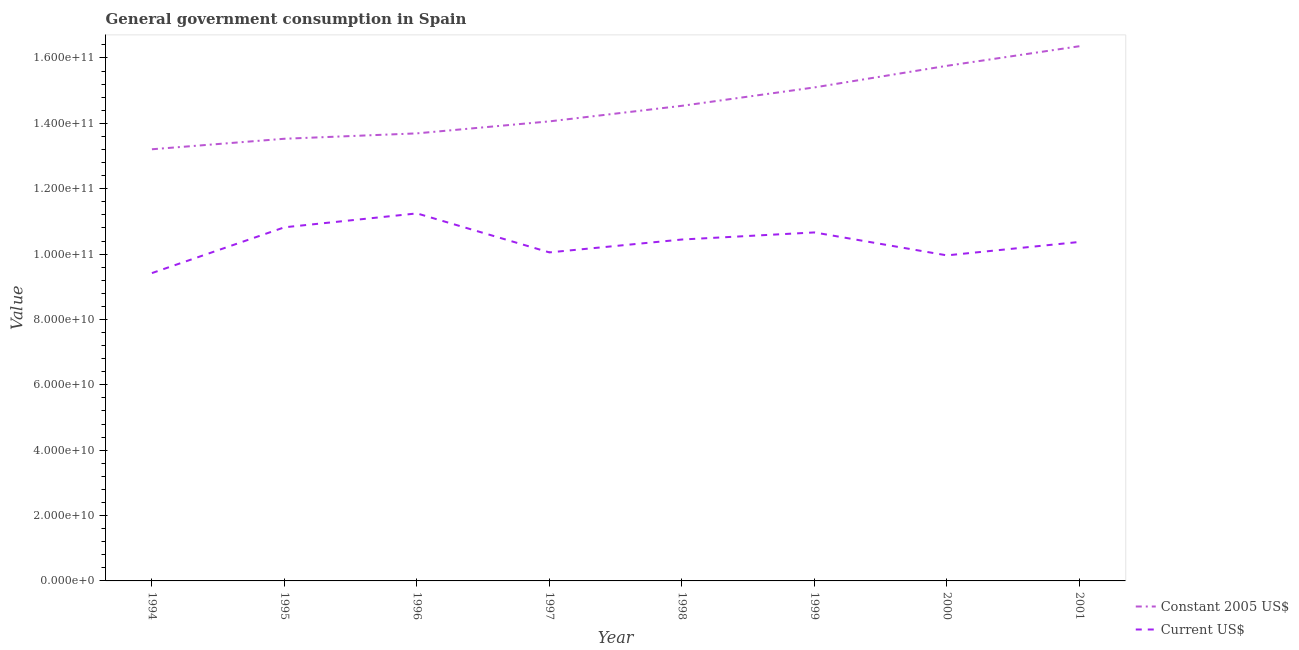How many different coloured lines are there?
Your response must be concise. 2. Does the line corresponding to value consumed in current us$ intersect with the line corresponding to value consumed in constant 2005 us$?
Your response must be concise. No. What is the value consumed in current us$ in 1996?
Provide a short and direct response. 1.12e+11. Across all years, what is the maximum value consumed in constant 2005 us$?
Offer a terse response. 1.64e+11. Across all years, what is the minimum value consumed in constant 2005 us$?
Make the answer very short. 1.32e+11. What is the total value consumed in constant 2005 us$ in the graph?
Provide a succinct answer. 1.16e+12. What is the difference between the value consumed in constant 2005 us$ in 1994 and that in 1998?
Your answer should be very brief. -1.33e+1. What is the difference between the value consumed in constant 2005 us$ in 1994 and the value consumed in current us$ in 1995?
Ensure brevity in your answer.  2.39e+1. What is the average value consumed in current us$ per year?
Make the answer very short. 1.04e+11. In the year 1998, what is the difference between the value consumed in constant 2005 us$ and value consumed in current us$?
Your answer should be very brief. 4.09e+1. In how many years, is the value consumed in constant 2005 us$ greater than 60000000000?
Provide a short and direct response. 8. What is the ratio of the value consumed in constant 2005 us$ in 1996 to that in 1999?
Your answer should be compact. 0.91. Is the value consumed in constant 2005 us$ in 1997 less than that in 1998?
Ensure brevity in your answer.  Yes. What is the difference between the highest and the second highest value consumed in current us$?
Provide a short and direct response. 4.25e+09. What is the difference between the highest and the lowest value consumed in current us$?
Keep it short and to the point. 1.83e+1. Is the sum of the value consumed in current us$ in 1997 and 1999 greater than the maximum value consumed in constant 2005 us$ across all years?
Offer a very short reply. Yes. Is the value consumed in current us$ strictly greater than the value consumed in constant 2005 us$ over the years?
Keep it short and to the point. No. How many lines are there?
Give a very brief answer. 2. What is the difference between two consecutive major ticks on the Y-axis?
Ensure brevity in your answer.  2.00e+1. Are the values on the major ticks of Y-axis written in scientific E-notation?
Provide a short and direct response. Yes. Does the graph contain any zero values?
Give a very brief answer. No. Does the graph contain grids?
Your answer should be very brief. No. How many legend labels are there?
Offer a very short reply. 2. How are the legend labels stacked?
Offer a very short reply. Vertical. What is the title of the graph?
Your response must be concise. General government consumption in Spain. Does "Non-resident workers" appear as one of the legend labels in the graph?
Ensure brevity in your answer.  No. What is the label or title of the X-axis?
Keep it short and to the point. Year. What is the label or title of the Y-axis?
Make the answer very short. Value. What is the Value in Constant 2005 US$ in 1994?
Keep it short and to the point. 1.32e+11. What is the Value in Current US$ in 1994?
Your answer should be compact. 9.42e+1. What is the Value of Constant 2005 US$ in 1995?
Keep it short and to the point. 1.35e+11. What is the Value of Current US$ in 1995?
Provide a succinct answer. 1.08e+11. What is the Value in Constant 2005 US$ in 1996?
Offer a terse response. 1.37e+11. What is the Value of Current US$ in 1996?
Provide a short and direct response. 1.12e+11. What is the Value in Constant 2005 US$ in 1997?
Your answer should be compact. 1.41e+11. What is the Value in Current US$ in 1997?
Your answer should be very brief. 1.01e+11. What is the Value in Constant 2005 US$ in 1998?
Offer a terse response. 1.45e+11. What is the Value in Current US$ in 1998?
Give a very brief answer. 1.04e+11. What is the Value of Constant 2005 US$ in 1999?
Offer a terse response. 1.51e+11. What is the Value in Current US$ in 1999?
Ensure brevity in your answer.  1.07e+11. What is the Value in Constant 2005 US$ in 2000?
Your answer should be very brief. 1.58e+11. What is the Value in Current US$ in 2000?
Provide a short and direct response. 9.96e+1. What is the Value of Constant 2005 US$ in 2001?
Ensure brevity in your answer.  1.64e+11. What is the Value in Current US$ in 2001?
Keep it short and to the point. 1.04e+11. Across all years, what is the maximum Value of Constant 2005 US$?
Your answer should be very brief. 1.64e+11. Across all years, what is the maximum Value in Current US$?
Offer a terse response. 1.12e+11. Across all years, what is the minimum Value in Constant 2005 US$?
Offer a very short reply. 1.32e+11. Across all years, what is the minimum Value of Current US$?
Offer a very short reply. 9.42e+1. What is the total Value of Constant 2005 US$ in the graph?
Offer a terse response. 1.16e+12. What is the total Value of Current US$ in the graph?
Give a very brief answer. 8.30e+11. What is the difference between the Value in Constant 2005 US$ in 1994 and that in 1995?
Provide a succinct answer. -3.22e+09. What is the difference between the Value of Current US$ in 1994 and that in 1995?
Provide a succinct answer. -1.40e+1. What is the difference between the Value of Constant 2005 US$ in 1994 and that in 1996?
Offer a terse response. -4.86e+09. What is the difference between the Value in Current US$ in 1994 and that in 1996?
Give a very brief answer. -1.83e+1. What is the difference between the Value of Constant 2005 US$ in 1994 and that in 1997?
Keep it short and to the point. -8.53e+09. What is the difference between the Value of Current US$ in 1994 and that in 1997?
Make the answer very short. -6.33e+09. What is the difference between the Value in Constant 2005 US$ in 1994 and that in 1998?
Make the answer very short. -1.33e+1. What is the difference between the Value in Current US$ in 1994 and that in 1998?
Offer a very short reply. -1.03e+1. What is the difference between the Value in Constant 2005 US$ in 1994 and that in 1999?
Your answer should be very brief. -1.89e+1. What is the difference between the Value in Current US$ in 1994 and that in 1999?
Offer a very short reply. -1.24e+1. What is the difference between the Value of Constant 2005 US$ in 1994 and that in 2000?
Provide a succinct answer. -2.55e+1. What is the difference between the Value in Current US$ in 1994 and that in 2000?
Ensure brevity in your answer.  -5.42e+09. What is the difference between the Value in Constant 2005 US$ in 1994 and that in 2001?
Give a very brief answer. -3.15e+1. What is the difference between the Value in Current US$ in 1994 and that in 2001?
Offer a terse response. -9.53e+09. What is the difference between the Value in Constant 2005 US$ in 1995 and that in 1996?
Provide a short and direct response. -1.65e+09. What is the difference between the Value of Current US$ in 1995 and that in 1996?
Your response must be concise. -4.25e+09. What is the difference between the Value in Constant 2005 US$ in 1995 and that in 1997?
Keep it short and to the point. -5.32e+09. What is the difference between the Value in Current US$ in 1995 and that in 1997?
Ensure brevity in your answer.  7.68e+09. What is the difference between the Value in Constant 2005 US$ in 1995 and that in 1998?
Your answer should be compact. -1.01e+1. What is the difference between the Value of Current US$ in 1995 and that in 1998?
Keep it short and to the point. 3.74e+09. What is the difference between the Value in Constant 2005 US$ in 1995 and that in 1999?
Your answer should be very brief. -1.57e+1. What is the difference between the Value in Current US$ in 1995 and that in 1999?
Provide a succinct answer. 1.57e+09. What is the difference between the Value of Constant 2005 US$ in 1995 and that in 2000?
Keep it short and to the point. -2.23e+1. What is the difference between the Value in Current US$ in 1995 and that in 2000?
Offer a very short reply. 8.59e+09. What is the difference between the Value of Constant 2005 US$ in 1995 and that in 2001?
Ensure brevity in your answer.  -2.83e+1. What is the difference between the Value in Current US$ in 1995 and that in 2001?
Your answer should be very brief. 4.48e+09. What is the difference between the Value in Constant 2005 US$ in 1996 and that in 1997?
Your answer should be very brief. -3.67e+09. What is the difference between the Value in Current US$ in 1996 and that in 1997?
Make the answer very short. 1.19e+1. What is the difference between the Value in Constant 2005 US$ in 1996 and that in 1998?
Make the answer very short. -8.43e+09. What is the difference between the Value of Current US$ in 1996 and that in 1998?
Make the answer very short. 7.99e+09. What is the difference between the Value in Constant 2005 US$ in 1996 and that in 1999?
Your answer should be compact. -1.41e+1. What is the difference between the Value in Current US$ in 1996 and that in 1999?
Offer a terse response. 5.82e+09. What is the difference between the Value in Constant 2005 US$ in 1996 and that in 2000?
Offer a terse response. -2.07e+1. What is the difference between the Value of Current US$ in 1996 and that in 2000?
Make the answer very short. 1.28e+1. What is the difference between the Value in Constant 2005 US$ in 1996 and that in 2001?
Make the answer very short. -2.67e+1. What is the difference between the Value in Current US$ in 1996 and that in 2001?
Ensure brevity in your answer.  8.74e+09. What is the difference between the Value in Constant 2005 US$ in 1997 and that in 1998?
Make the answer very short. -4.76e+09. What is the difference between the Value in Current US$ in 1997 and that in 1998?
Offer a very short reply. -3.94e+09. What is the difference between the Value of Constant 2005 US$ in 1997 and that in 1999?
Provide a short and direct response. -1.04e+1. What is the difference between the Value of Current US$ in 1997 and that in 1999?
Your answer should be compact. -6.11e+09. What is the difference between the Value in Constant 2005 US$ in 1997 and that in 2000?
Your response must be concise. -1.70e+1. What is the difference between the Value of Current US$ in 1997 and that in 2000?
Give a very brief answer. 9.12e+08. What is the difference between the Value in Constant 2005 US$ in 1997 and that in 2001?
Give a very brief answer. -2.30e+1. What is the difference between the Value of Current US$ in 1997 and that in 2001?
Make the answer very short. -3.20e+09. What is the difference between the Value of Constant 2005 US$ in 1998 and that in 1999?
Your response must be concise. -5.63e+09. What is the difference between the Value of Current US$ in 1998 and that in 1999?
Your response must be concise. -2.17e+09. What is the difference between the Value in Constant 2005 US$ in 1998 and that in 2000?
Ensure brevity in your answer.  -1.22e+1. What is the difference between the Value of Current US$ in 1998 and that in 2000?
Your answer should be very brief. 4.85e+09. What is the difference between the Value of Constant 2005 US$ in 1998 and that in 2001?
Give a very brief answer. -1.82e+1. What is the difference between the Value of Current US$ in 1998 and that in 2001?
Give a very brief answer. 7.44e+08. What is the difference between the Value in Constant 2005 US$ in 1999 and that in 2000?
Keep it short and to the point. -6.61e+09. What is the difference between the Value in Current US$ in 1999 and that in 2000?
Your answer should be very brief. 7.02e+09. What is the difference between the Value in Constant 2005 US$ in 1999 and that in 2001?
Make the answer very short. -1.26e+1. What is the difference between the Value of Current US$ in 1999 and that in 2001?
Provide a succinct answer. 2.91e+09. What is the difference between the Value of Constant 2005 US$ in 2000 and that in 2001?
Your answer should be compact. -6.00e+09. What is the difference between the Value in Current US$ in 2000 and that in 2001?
Your response must be concise. -4.11e+09. What is the difference between the Value of Constant 2005 US$ in 1994 and the Value of Current US$ in 1995?
Offer a very short reply. 2.39e+1. What is the difference between the Value of Constant 2005 US$ in 1994 and the Value of Current US$ in 1996?
Provide a succinct answer. 1.96e+1. What is the difference between the Value in Constant 2005 US$ in 1994 and the Value in Current US$ in 1997?
Provide a short and direct response. 3.16e+1. What is the difference between the Value of Constant 2005 US$ in 1994 and the Value of Current US$ in 1998?
Offer a very short reply. 2.76e+1. What is the difference between the Value of Constant 2005 US$ in 1994 and the Value of Current US$ in 1999?
Offer a terse response. 2.54e+1. What is the difference between the Value in Constant 2005 US$ in 1994 and the Value in Current US$ in 2000?
Offer a very short reply. 3.25e+1. What is the difference between the Value of Constant 2005 US$ in 1994 and the Value of Current US$ in 2001?
Your answer should be compact. 2.84e+1. What is the difference between the Value in Constant 2005 US$ in 1995 and the Value in Current US$ in 1996?
Your response must be concise. 2.28e+1. What is the difference between the Value in Constant 2005 US$ in 1995 and the Value in Current US$ in 1997?
Ensure brevity in your answer.  3.48e+1. What is the difference between the Value in Constant 2005 US$ in 1995 and the Value in Current US$ in 1998?
Your answer should be compact. 3.08e+1. What is the difference between the Value in Constant 2005 US$ in 1995 and the Value in Current US$ in 1999?
Provide a succinct answer. 2.87e+1. What is the difference between the Value in Constant 2005 US$ in 1995 and the Value in Current US$ in 2000?
Your answer should be very brief. 3.57e+1. What is the difference between the Value of Constant 2005 US$ in 1995 and the Value of Current US$ in 2001?
Keep it short and to the point. 3.16e+1. What is the difference between the Value in Constant 2005 US$ in 1996 and the Value in Current US$ in 1997?
Keep it short and to the point. 3.64e+1. What is the difference between the Value of Constant 2005 US$ in 1996 and the Value of Current US$ in 1998?
Provide a succinct answer. 3.25e+1. What is the difference between the Value in Constant 2005 US$ in 1996 and the Value in Current US$ in 1999?
Keep it short and to the point. 3.03e+1. What is the difference between the Value in Constant 2005 US$ in 1996 and the Value in Current US$ in 2000?
Your answer should be compact. 3.73e+1. What is the difference between the Value of Constant 2005 US$ in 1996 and the Value of Current US$ in 2001?
Your answer should be compact. 3.32e+1. What is the difference between the Value of Constant 2005 US$ in 1997 and the Value of Current US$ in 1998?
Your response must be concise. 3.61e+1. What is the difference between the Value in Constant 2005 US$ in 1997 and the Value in Current US$ in 1999?
Give a very brief answer. 3.40e+1. What is the difference between the Value in Constant 2005 US$ in 1997 and the Value in Current US$ in 2000?
Offer a very short reply. 4.10e+1. What is the difference between the Value in Constant 2005 US$ in 1997 and the Value in Current US$ in 2001?
Ensure brevity in your answer.  3.69e+1. What is the difference between the Value of Constant 2005 US$ in 1998 and the Value of Current US$ in 1999?
Your response must be concise. 3.87e+1. What is the difference between the Value in Constant 2005 US$ in 1998 and the Value in Current US$ in 2000?
Provide a succinct answer. 4.58e+1. What is the difference between the Value of Constant 2005 US$ in 1998 and the Value of Current US$ in 2001?
Your answer should be very brief. 4.17e+1. What is the difference between the Value of Constant 2005 US$ in 1999 and the Value of Current US$ in 2000?
Provide a short and direct response. 5.14e+1. What is the difference between the Value in Constant 2005 US$ in 1999 and the Value in Current US$ in 2001?
Provide a short and direct response. 4.73e+1. What is the difference between the Value in Constant 2005 US$ in 2000 and the Value in Current US$ in 2001?
Keep it short and to the point. 5.39e+1. What is the average Value in Constant 2005 US$ per year?
Offer a very short reply. 1.45e+11. What is the average Value in Current US$ per year?
Your answer should be very brief. 1.04e+11. In the year 1994, what is the difference between the Value of Constant 2005 US$ and Value of Current US$?
Your answer should be very brief. 3.79e+1. In the year 1995, what is the difference between the Value in Constant 2005 US$ and Value in Current US$?
Give a very brief answer. 2.71e+1. In the year 1996, what is the difference between the Value of Constant 2005 US$ and Value of Current US$?
Your response must be concise. 2.45e+1. In the year 1997, what is the difference between the Value in Constant 2005 US$ and Value in Current US$?
Offer a terse response. 4.01e+1. In the year 1998, what is the difference between the Value in Constant 2005 US$ and Value in Current US$?
Ensure brevity in your answer.  4.09e+1. In the year 1999, what is the difference between the Value of Constant 2005 US$ and Value of Current US$?
Your answer should be compact. 4.44e+1. In the year 2000, what is the difference between the Value in Constant 2005 US$ and Value in Current US$?
Your answer should be very brief. 5.80e+1. In the year 2001, what is the difference between the Value of Constant 2005 US$ and Value of Current US$?
Provide a succinct answer. 5.99e+1. What is the ratio of the Value of Constant 2005 US$ in 1994 to that in 1995?
Make the answer very short. 0.98. What is the ratio of the Value of Current US$ in 1994 to that in 1995?
Provide a succinct answer. 0.87. What is the ratio of the Value in Constant 2005 US$ in 1994 to that in 1996?
Your answer should be compact. 0.96. What is the ratio of the Value of Current US$ in 1994 to that in 1996?
Your answer should be very brief. 0.84. What is the ratio of the Value in Constant 2005 US$ in 1994 to that in 1997?
Your answer should be very brief. 0.94. What is the ratio of the Value in Current US$ in 1994 to that in 1997?
Ensure brevity in your answer.  0.94. What is the ratio of the Value in Constant 2005 US$ in 1994 to that in 1998?
Your response must be concise. 0.91. What is the ratio of the Value in Current US$ in 1994 to that in 1998?
Your response must be concise. 0.9. What is the ratio of the Value in Constant 2005 US$ in 1994 to that in 1999?
Make the answer very short. 0.87. What is the ratio of the Value in Current US$ in 1994 to that in 1999?
Offer a very short reply. 0.88. What is the ratio of the Value of Constant 2005 US$ in 1994 to that in 2000?
Offer a terse response. 0.84. What is the ratio of the Value of Current US$ in 1994 to that in 2000?
Offer a terse response. 0.95. What is the ratio of the Value of Constant 2005 US$ in 1994 to that in 2001?
Your response must be concise. 0.81. What is the ratio of the Value in Current US$ in 1994 to that in 2001?
Give a very brief answer. 0.91. What is the ratio of the Value of Current US$ in 1995 to that in 1996?
Offer a terse response. 0.96. What is the ratio of the Value of Constant 2005 US$ in 1995 to that in 1997?
Keep it short and to the point. 0.96. What is the ratio of the Value in Current US$ in 1995 to that in 1997?
Your answer should be very brief. 1.08. What is the ratio of the Value of Constant 2005 US$ in 1995 to that in 1998?
Your response must be concise. 0.93. What is the ratio of the Value in Current US$ in 1995 to that in 1998?
Make the answer very short. 1.04. What is the ratio of the Value in Constant 2005 US$ in 1995 to that in 1999?
Make the answer very short. 0.9. What is the ratio of the Value in Current US$ in 1995 to that in 1999?
Offer a terse response. 1.01. What is the ratio of the Value of Constant 2005 US$ in 1995 to that in 2000?
Offer a very short reply. 0.86. What is the ratio of the Value of Current US$ in 1995 to that in 2000?
Your answer should be compact. 1.09. What is the ratio of the Value in Constant 2005 US$ in 1995 to that in 2001?
Your answer should be very brief. 0.83. What is the ratio of the Value in Current US$ in 1995 to that in 2001?
Provide a succinct answer. 1.04. What is the ratio of the Value of Constant 2005 US$ in 1996 to that in 1997?
Your answer should be very brief. 0.97. What is the ratio of the Value in Current US$ in 1996 to that in 1997?
Your answer should be very brief. 1.12. What is the ratio of the Value of Constant 2005 US$ in 1996 to that in 1998?
Provide a succinct answer. 0.94. What is the ratio of the Value of Current US$ in 1996 to that in 1998?
Ensure brevity in your answer.  1.08. What is the ratio of the Value in Constant 2005 US$ in 1996 to that in 1999?
Provide a short and direct response. 0.91. What is the ratio of the Value in Current US$ in 1996 to that in 1999?
Your answer should be compact. 1.05. What is the ratio of the Value in Constant 2005 US$ in 1996 to that in 2000?
Ensure brevity in your answer.  0.87. What is the ratio of the Value in Current US$ in 1996 to that in 2000?
Make the answer very short. 1.13. What is the ratio of the Value of Constant 2005 US$ in 1996 to that in 2001?
Keep it short and to the point. 0.84. What is the ratio of the Value of Current US$ in 1996 to that in 2001?
Provide a succinct answer. 1.08. What is the ratio of the Value in Constant 2005 US$ in 1997 to that in 1998?
Your answer should be very brief. 0.97. What is the ratio of the Value of Current US$ in 1997 to that in 1998?
Give a very brief answer. 0.96. What is the ratio of the Value of Constant 2005 US$ in 1997 to that in 1999?
Ensure brevity in your answer.  0.93. What is the ratio of the Value of Current US$ in 1997 to that in 1999?
Your response must be concise. 0.94. What is the ratio of the Value of Constant 2005 US$ in 1997 to that in 2000?
Ensure brevity in your answer.  0.89. What is the ratio of the Value of Current US$ in 1997 to that in 2000?
Provide a succinct answer. 1.01. What is the ratio of the Value in Constant 2005 US$ in 1997 to that in 2001?
Provide a short and direct response. 0.86. What is the ratio of the Value of Current US$ in 1997 to that in 2001?
Your answer should be very brief. 0.97. What is the ratio of the Value of Constant 2005 US$ in 1998 to that in 1999?
Provide a succinct answer. 0.96. What is the ratio of the Value in Current US$ in 1998 to that in 1999?
Your answer should be very brief. 0.98. What is the ratio of the Value in Constant 2005 US$ in 1998 to that in 2000?
Offer a terse response. 0.92. What is the ratio of the Value in Current US$ in 1998 to that in 2000?
Provide a succinct answer. 1.05. What is the ratio of the Value of Constant 2005 US$ in 1998 to that in 2001?
Your answer should be compact. 0.89. What is the ratio of the Value of Current US$ in 1998 to that in 2001?
Provide a succinct answer. 1.01. What is the ratio of the Value in Constant 2005 US$ in 1999 to that in 2000?
Your answer should be compact. 0.96. What is the ratio of the Value in Current US$ in 1999 to that in 2000?
Ensure brevity in your answer.  1.07. What is the ratio of the Value in Constant 2005 US$ in 1999 to that in 2001?
Provide a short and direct response. 0.92. What is the ratio of the Value in Current US$ in 1999 to that in 2001?
Keep it short and to the point. 1.03. What is the ratio of the Value in Constant 2005 US$ in 2000 to that in 2001?
Your response must be concise. 0.96. What is the ratio of the Value of Current US$ in 2000 to that in 2001?
Keep it short and to the point. 0.96. What is the difference between the highest and the second highest Value in Constant 2005 US$?
Offer a very short reply. 6.00e+09. What is the difference between the highest and the second highest Value in Current US$?
Provide a succinct answer. 4.25e+09. What is the difference between the highest and the lowest Value of Constant 2005 US$?
Offer a very short reply. 3.15e+1. What is the difference between the highest and the lowest Value of Current US$?
Your answer should be compact. 1.83e+1. 